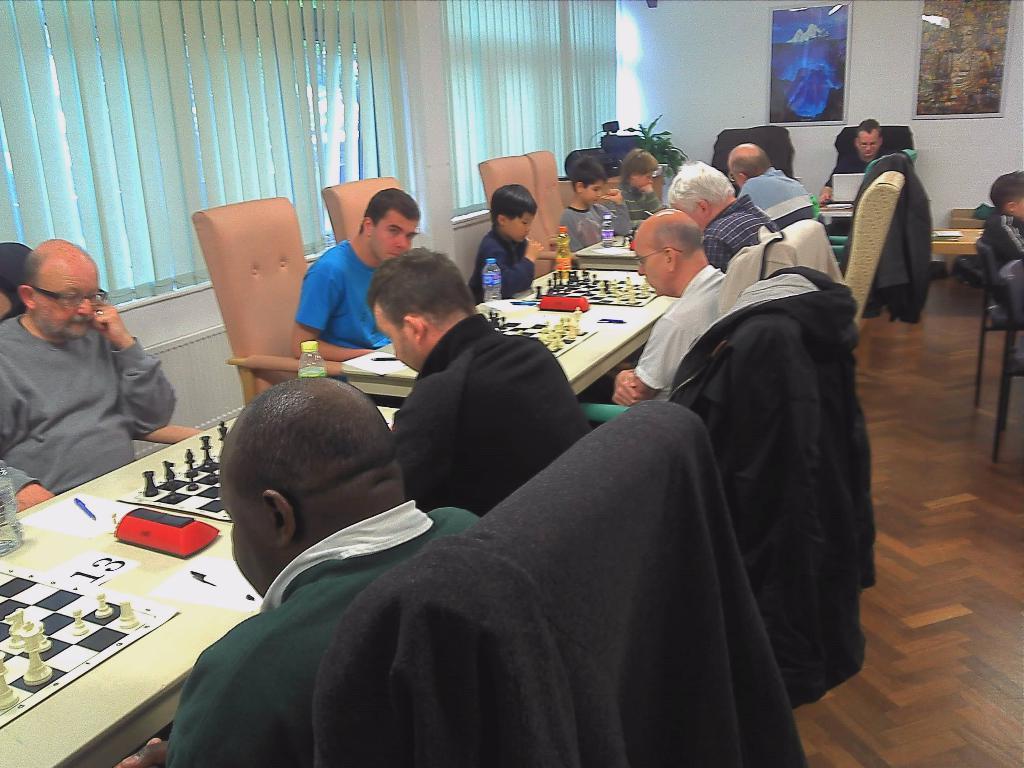Could you give a brief overview of what you see in this image? In this picture we can see some group of people sitting in front of a table and playing a chess game, in the background there is a wall and there are two portraits here, on the left side of this image we can see a window blind, on the table there is a chess board,in the background there is one plant. 